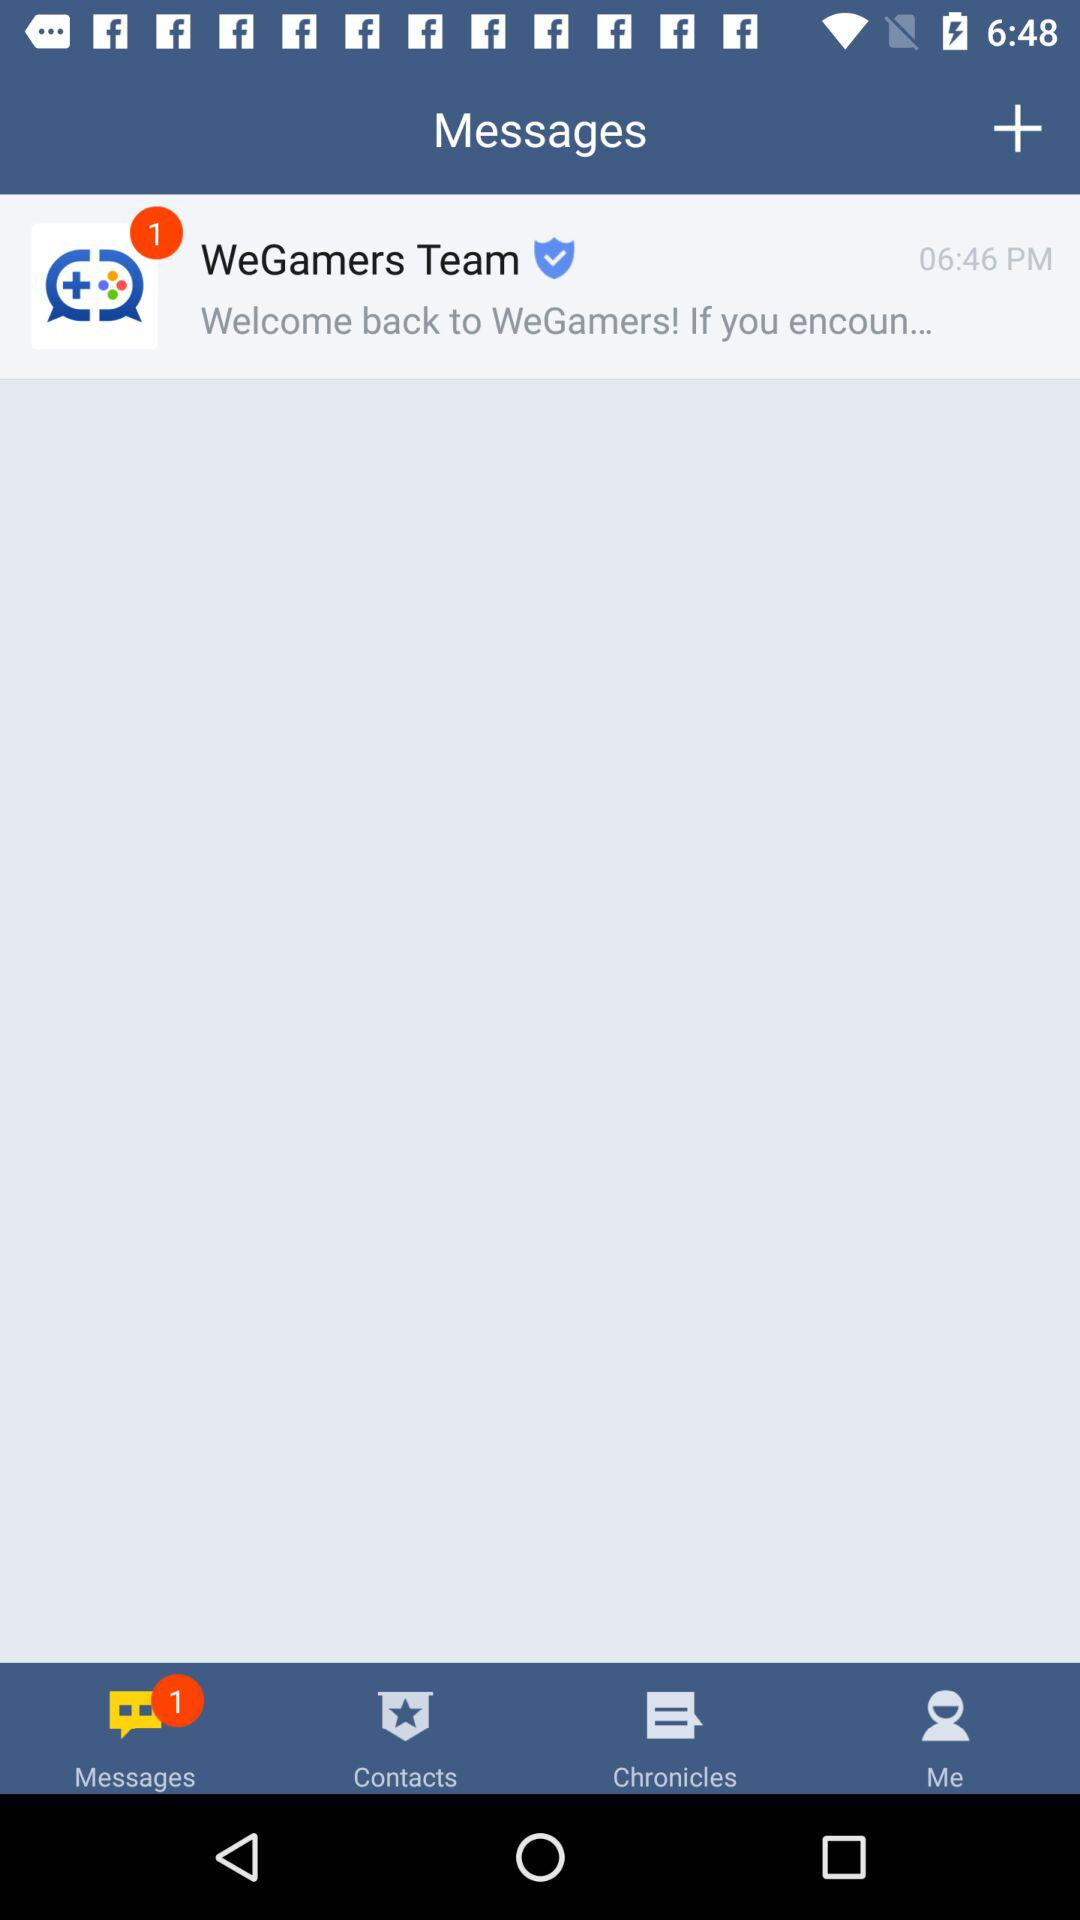At what time was the message received? The message was received at 06:46 PM. 